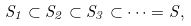<formula> <loc_0><loc_0><loc_500><loc_500>S _ { 1 } \subset S _ { 2 } \subset S _ { 3 } \subset \cdots = S ,</formula> 